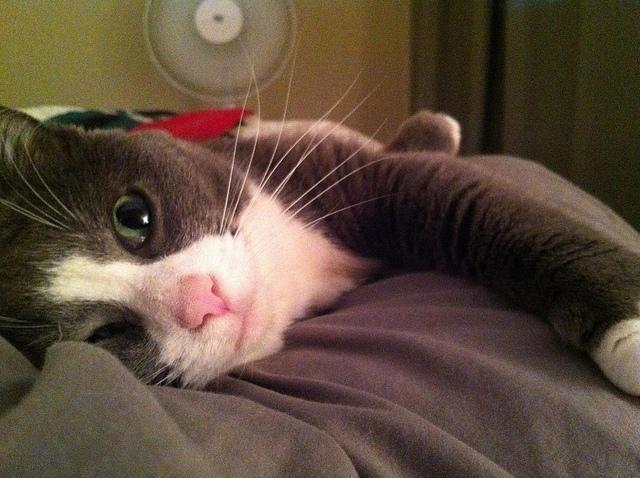How many beds are in the picture?
Give a very brief answer. 1. 